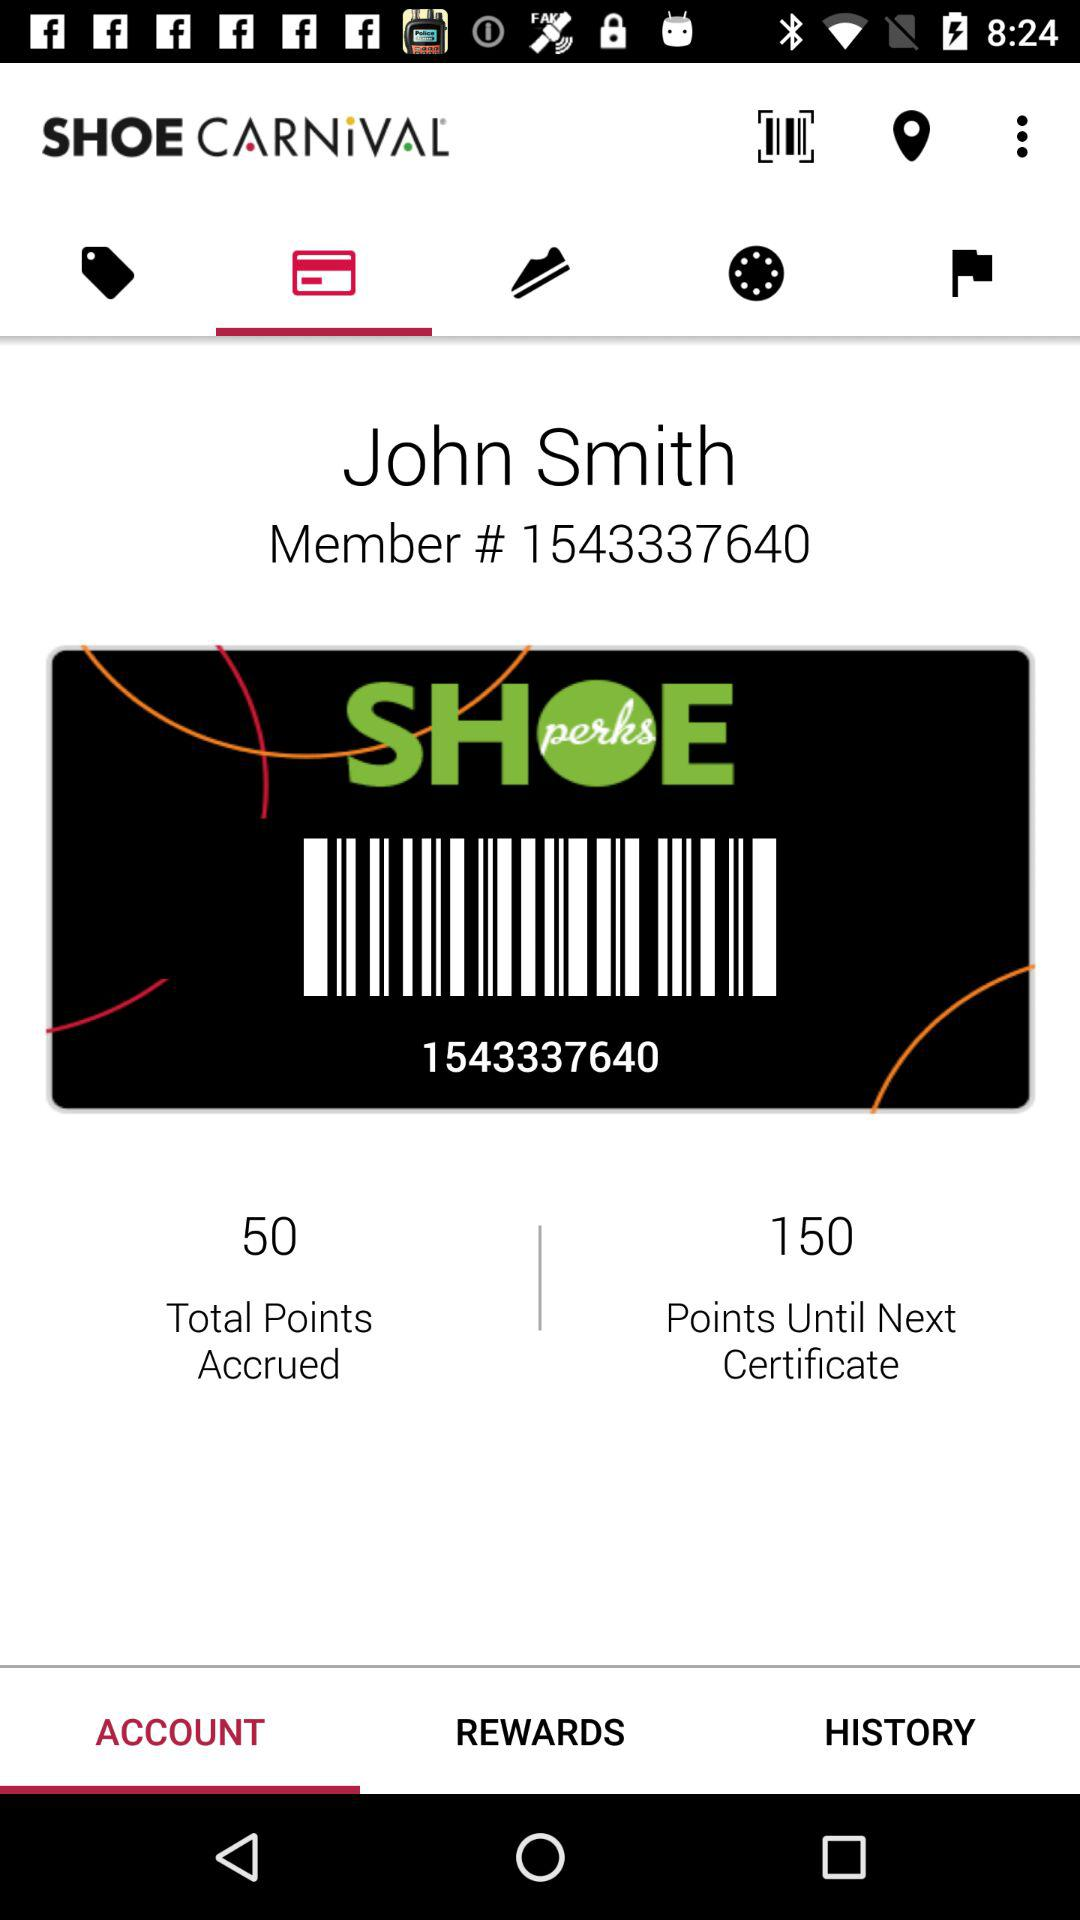How many accrued points in total are there? There are total 50 accrued points. 